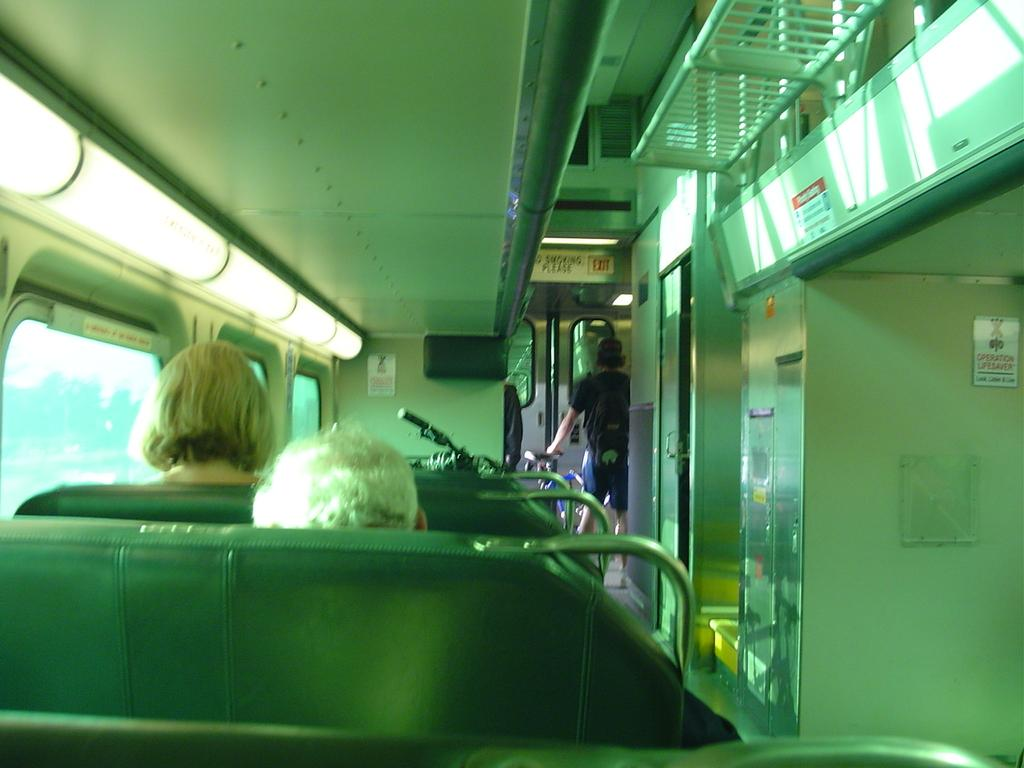What type of space is depicted in the image? The image shows the inside of a vehicle. Are there any occupants inside the vehicle? Yes, there are people inside the vehicle. What type of furniture is present in the vehicle? There are seats in the vehicle. What additional features can be seen in the vehicle? There are boards, a grille, glass windows, and lights in the vehicle. What type of stove is visible in the vehicle? There is no stove present in the vehicle; the image shows the interior of a vehicle with various features but no stove. 